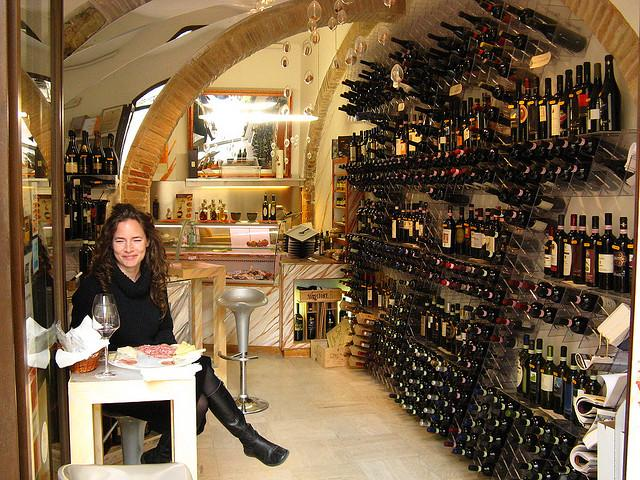What is the woman surrounded by? Please explain your reasoning. wine bottles. You can tell by the bottle shape and how they are stacked as to what type they are. 